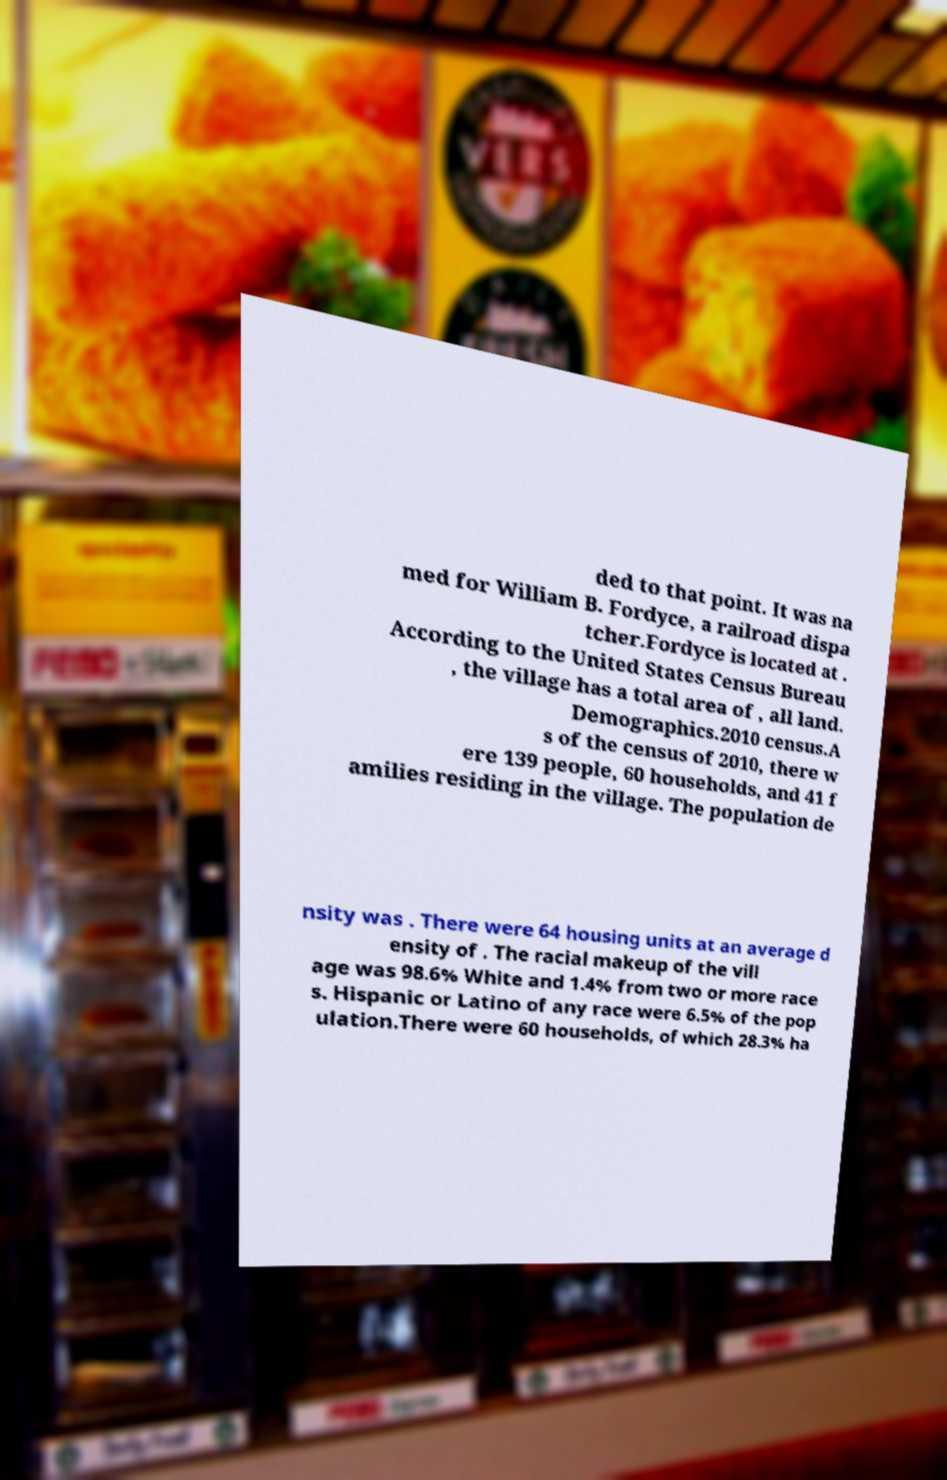For documentation purposes, I need the text within this image transcribed. Could you provide that? ded to that point. It was na med for William B. Fordyce, a railroad dispa tcher.Fordyce is located at . According to the United States Census Bureau , the village has a total area of , all land. Demographics.2010 census.A s of the census of 2010, there w ere 139 people, 60 households, and 41 f amilies residing in the village. The population de nsity was . There were 64 housing units at an average d ensity of . The racial makeup of the vill age was 98.6% White and 1.4% from two or more race s. Hispanic or Latino of any race were 6.5% of the pop ulation.There were 60 households, of which 28.3% ha 